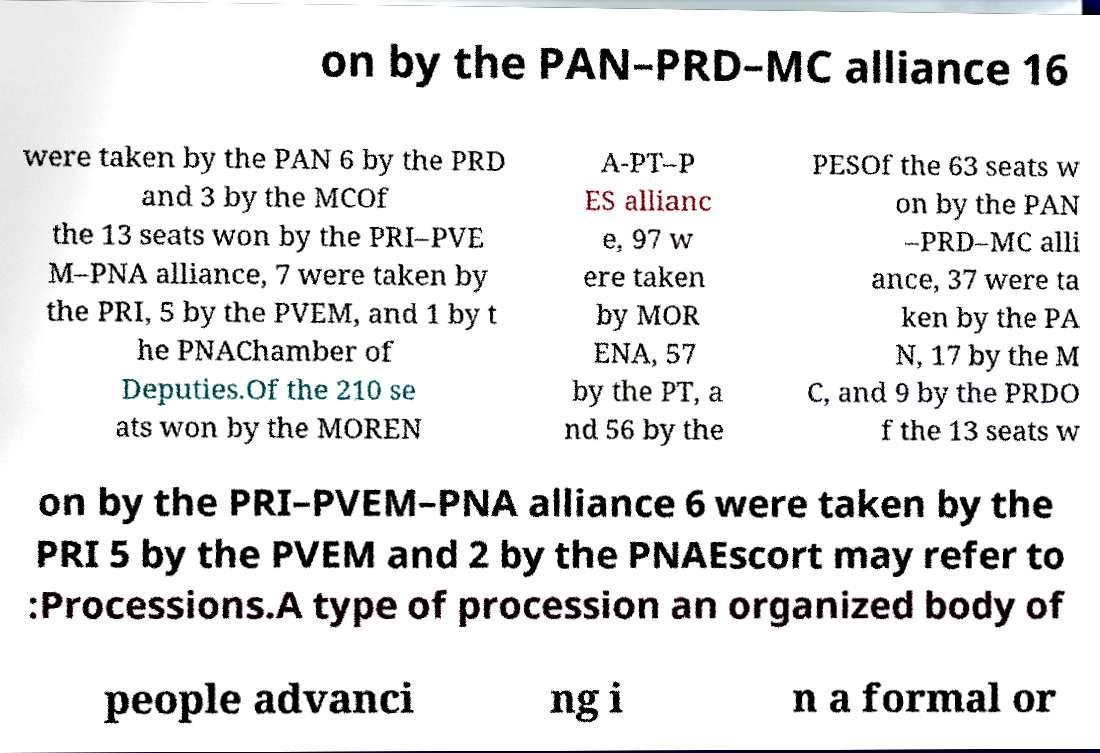Can you accurately transcribe the text from the provided image for me? on by the PAN–PRD–MC alliance 16 were taken by the PAN 6 by the PRD and 3 by the MCOf the 13 seats won by the PRI–PVE M–PNA alliance, 7 were taken by the PRI, 5 by the PVEM, and 1 by t he PNAChamber of Deputies.Of the 210 se ats won by the MOREN A-PT–P ES allianc e, 97 w ere taken by MOR ENA, 57 by the PT, a nd 56 by the PESOf the 63 seats w on by the PAN –PRD–MC alli ance, 37 were ta ken by the PA N, 17 by the M C, and 9 by the PRDO f the 13 seats w on by the PRI–PVEM–PNA alliance 6 were taken by the PRI 5 by the PVEM and 2 by the PNAEscort may refer to :Processions.A type of procession an organized body of people advanci ng i n a formal or 